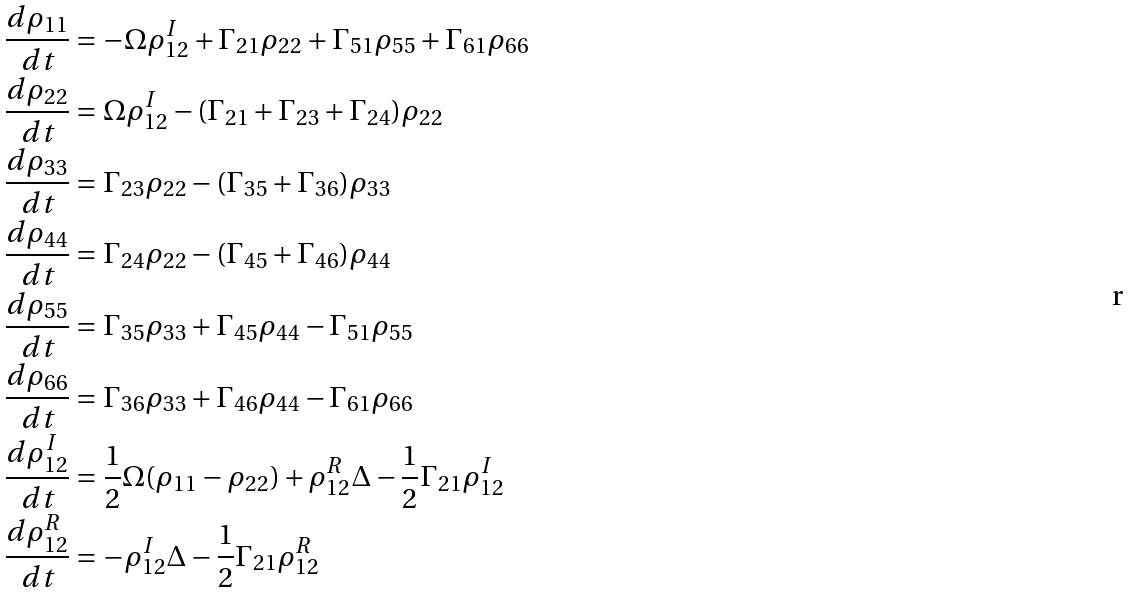Convert formula to latex. <formula><loc_0><loc_0><loc_500><loc_500>\frac { d \rho _ { 1 1 } } { d t } & = - \Omega \rho ^ { I } _ { 1 2 } + \Gamma _ { 2 1 } \rho _ { 2 2 } + \Gamma _ { 5 1 } \rho _ { 5 5 } + \Gamma _ { 6 1 } \rho _ { 6 6 } \\ \frac { d \rho _ { 2 2 } } { d t } & = \Omega \rho ^ { I } _ { 1 2 } - ( \Gamma _ { 2 1 } + \Gamma _ { 2 3 } + \Gamma _ { 2 4 } ) \rho _ { 2 2 } \\ \frac { d \rho _ { 3 3 } } { d t } & = \Gamma _ { 2 3 } \rho _ { 2 2 } - ( \Gamma _ { 3 5 } + \Gamma _ { 3 6 } ) \rho _ { 3 3 } \\ \frac { d \rho _ { 4 4 } } { d t } & = \Gamma _ { 2 4 } \rho _ { 2 2 } - ( \Gamma _ { 4 5 } + \Gamma _ { 4 6 } ) \rho _ { 4 4 } \\ \frac { d \rho _ { 5 5 } } { d t } & = \Gamma _ { 3 5 } \rho _ { 3 3 } + \Gamma _ { 4 5 } \rho _ { 4 4 } - \Gamma _ { 5 1 } \rho _ { 5 5 } \\ \frac { d \rho _ { 6 6 } } { d t } & = \Gamma _ { 3 6 } \rho _ { 3 3 } + \Gamma _ { 4 6 } \rho _ { 4 4 } - \Gamma _ { 6 1 } \rho _ { 6 6 } \\ \frac { d \rho ^ { I } _ { 1 2 } } { d t } & = \frac { 1 } { 2 } \Omega ( \rho _ { 1 1 } - \rho _ { 2 2 } ) + \rho ^ { R } _ { 1 2 } \Delta - \frac { 1 } { 2 } \Gamma _ { 2 1 } \rho ^ { I } _ { 1 2 } \\ \frac { d \rho ^ { R } _ { 1 2 } } { d t } & = - \rho ^ { I } _ { 1 2 } \Delta - \frac { 1 } { 2 } \Gamma _ { 2 1 } \rho ^ { R } _ { 1 2 }</formula> 